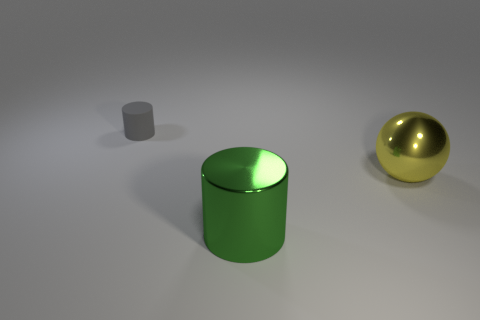What is the material of the object on the right side of the large object on the left side of the metallic ball?
Offer a very short reply. Metal. What color is the large cylinder?
Your answer should be compact. Green. What number of things are either large metallic objects that are behind the big cylinder or large cyan rubber cubes?
Provide a succinct answer. 1. There is a cylinder in front of the big yellow object; does it have the same size as the yellow object that is to the right of the green metal cylinder?
Give a very brief answer. Yes. Is there any other thing that has the same material as the small gray cylinder?
Ensure brevity in your answer.  No. How many things are either things that are to the left of the ball or gray matte objects that are behind the large yellow sphere?
Offer a terse response. 2. Does the big yellow ball have the same material as the thing on the left side of the large green object?
Make the answer very short. No. What shape is the object that is behind the large cylinder and in front of the small gray matte cylinder?
Your response must be concise. Sphere. The rubber thing is what shape?
Your response must be concise. Cylinder. There is a metallic object that is on the right side of the cylinder right of the matte thing; what is its color?
Ensure brevity in your answer.  Yellow. 